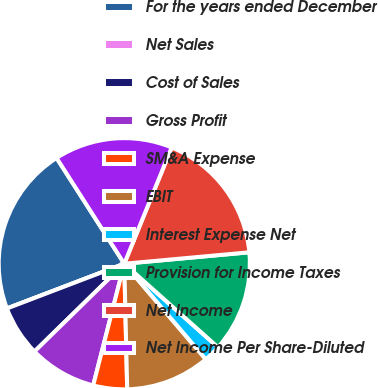Convert chart. <chart><loc_0><loc_0><loc_500><loc_500><pie_chart><fcel>For the years ended December<fcel>Net Sales<fcel>Cost of Sales<fcel>Gross Profit<fcel>SM&A Expense<fcel>EBIT<fcel>Interest Expense Net<fcel>Provision for Income Taxes<fcel>Net Income<fcel>Net Income Per Share-Diluted<nl><fcel>21.74%<fcel>0.0%<fcel>6.52%<fcel>8.7%<fcel>4.35%<fcel>10.87%<fcel>2.17%<fcel>13.04%<fcel>17.39%<fcel>15.22%<nl></chart> 